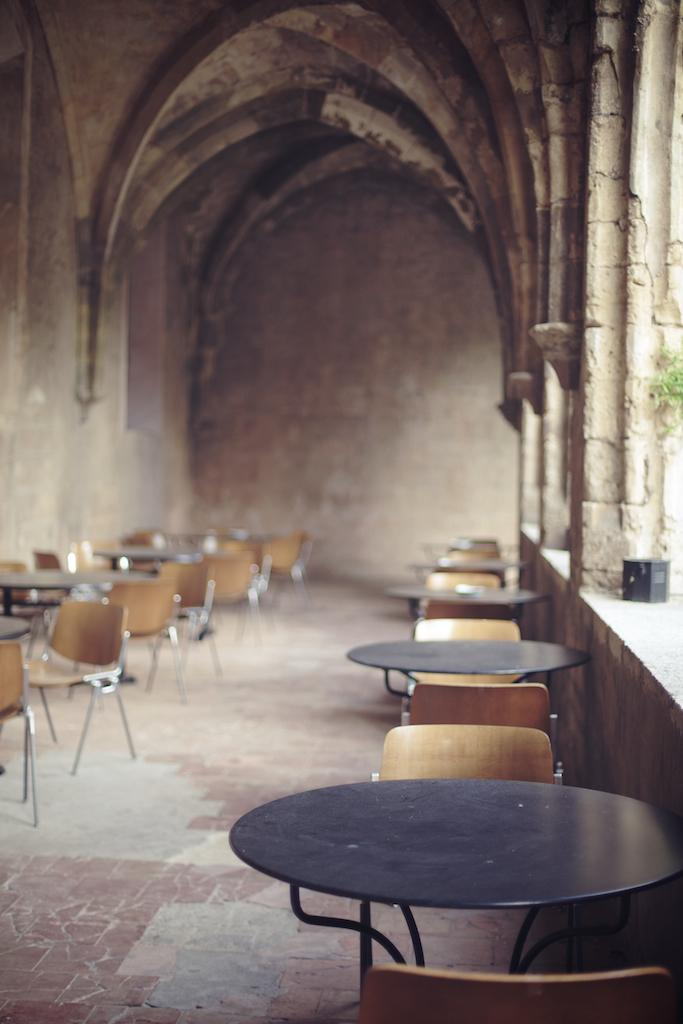What type of furniture can be seen on both sides of the image? There are tables on both the right and left sides of the image. What type of seating is present in the image? There are chairs in the image. What architectural features can be seen in the image? There are pillars visible in the image. What type of structure is present in the image? There is a wall in the image. What type of pathway is visible at the bottom of the image? There is a walkway at the bottom of the image. What color are the eyes of the family in the image? There is no family present in the image, and therefore no eyes to describe. What type of material is used to construct the brick wall in the image? There is no brick wall present in the image; it features a wall made of a different material. 